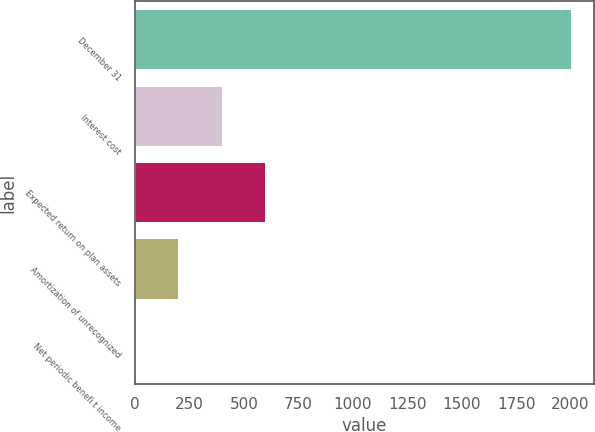<chart> <loc_0><loc_0><loc_500><loc_500><bar_chart><fcel>December 31<fcel>Interest cost<fcel>Expected return on plan assets<fcel>Amortization of unrecognized<fcel>Net periodic benefi t income<nl><fcel>2007<fcel>401.56<fcel>602.24<fcel>200.88<fcel>0.2<nl></chart> 